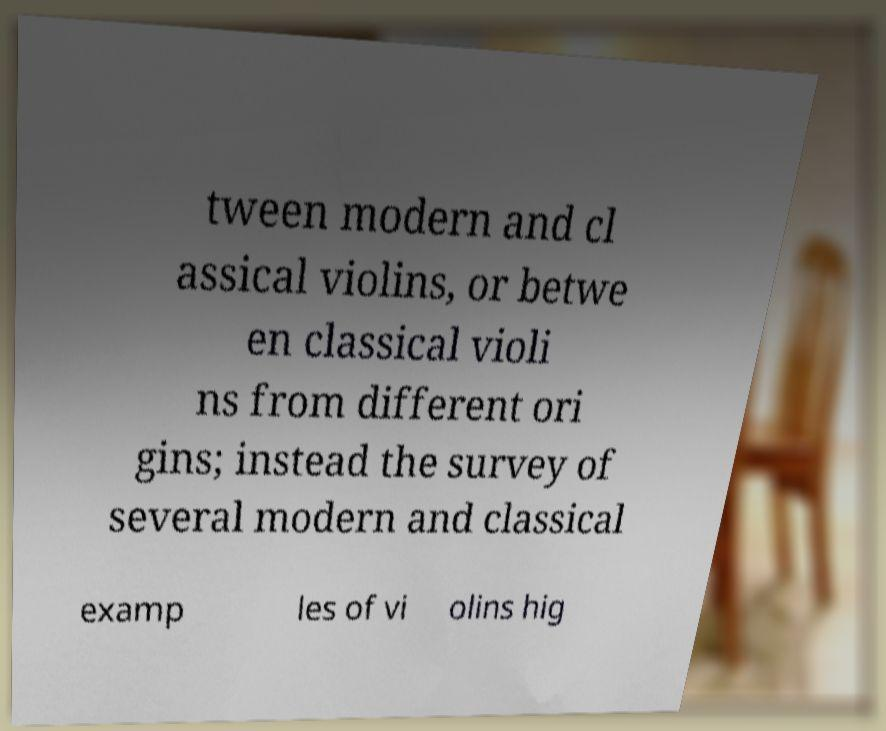Please identify and transcribe the text found in this image. tween modern and cl assical violins, or betwe en classical violi ns from different ori gins; instead the survey of several modern and classical examp les of vi olins hig 